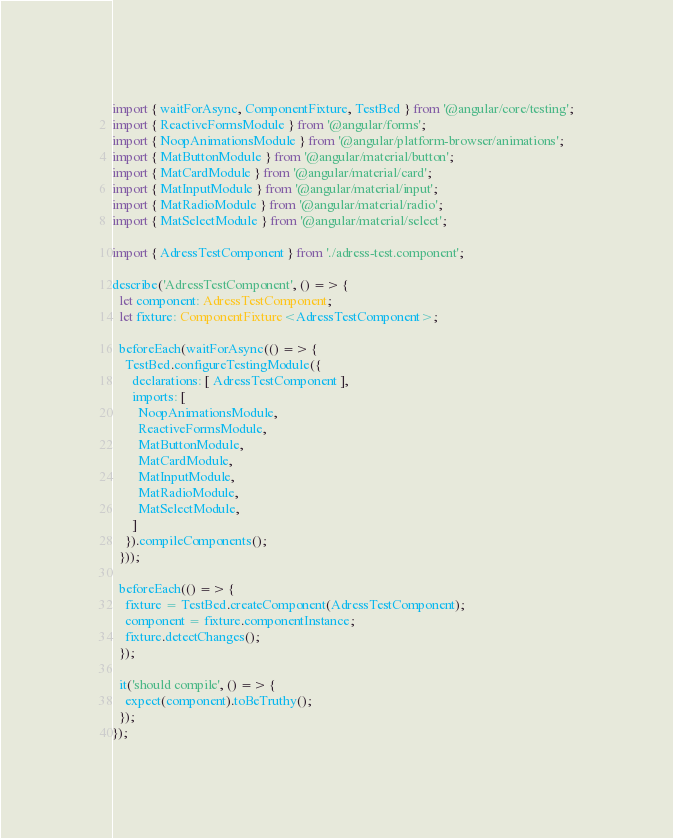Convert code to text. <code><loc_0><loc_0><loc_500><loc_500><_TypeScript_>import { waitForAsync, ComponentFixture, TestBed } from '@angular/core/testing';
import { ReactiveFormsModule } from '@angular/forms';
import { NoopAnimationsModule } from '@angular/platform-browser/animations';
import { MatButtonModule } from '@angular/material/button';
import { MatCardModule } from '@angular/material/card';
import { MatInputModule } from '@angular/material/input';
import { MatRadioModule } from '@angular/material/radio';
import { MatSelectModule } from '@angular/material/select';

import { AdressTestComponent } from './adress-test.component';

describe('AdressTestComponent', () => {
  let component: AdressTestComponent;
  let fixture: ComponentFixture<AdressTestComponent>;

  beforeEach(waitForAsync(() => {
    TestBed.configureTestingModule({
      declarations: [ AdressTestComponent ],
      imports: [
        NoopAnimationsModule,
        ReactiveFormsModule,
        MatButtonModule,
        MatCardModule,
        MatInputModule,
        MatRadioModule,
        MatSelectModule,
      ]
    }).compileComponents();
  }));

  beforeEach(() => {
    fixture = TestBed.createComponent(AdressTestComponent);
    component = fixture.componentInstance;
    fixture.detectChanges();
  });

  it('should compile', () => {
    expect(component).toBeTruthy();
  });
});
</code> 